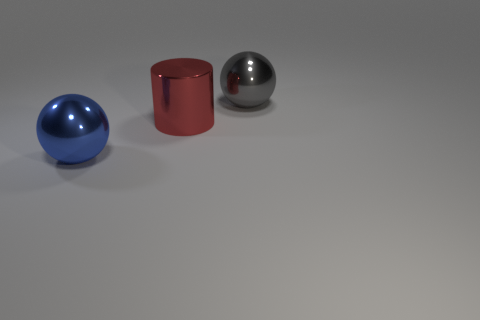Add 3 large green shiny spheres. How many objects exist? 6 Subtract all blue balls. How many balls are left? 1 Subtract all cylinders. How many objects are left? 2 Add 3 big blue things. How many big blue things are left? 4 Add 1 gray metal things. How many gray metal things exist? 2 Subtract 0 green blocks. How many objects are left? 3 Subtract 1 balls. How many balls are left? 1 Subtract all brown cylinders. Subtract all red balls. How many cylinders are left? 1 Subtract all big red cylinders. Subtract all blue things. How many objects are left? 1 